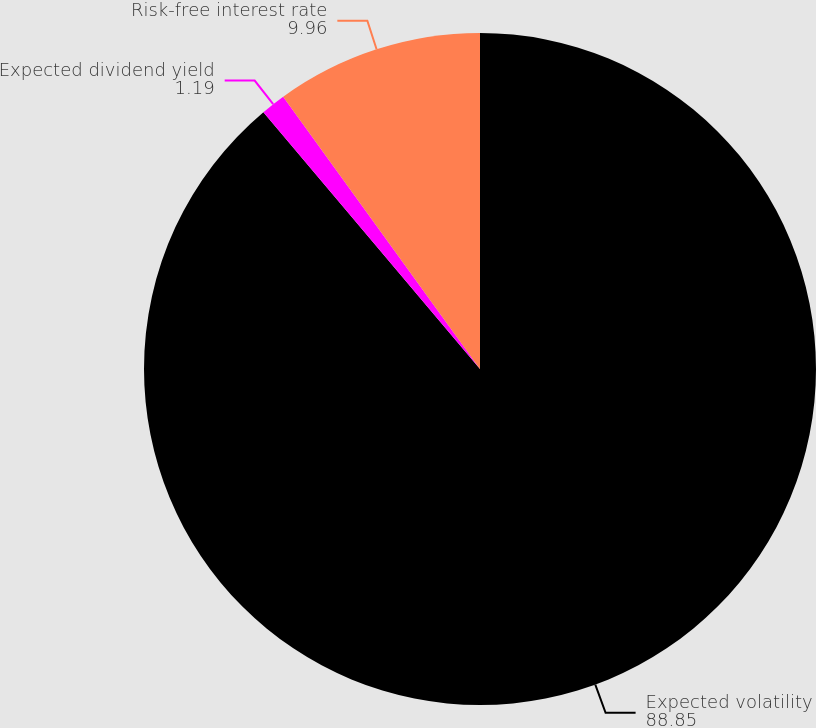<chart> <loc_0><loc_0><loc_500><loc_500><pie_chart><fcel>Expected volatility<fcel>Expected dividend yield<fcel>Risk-free interest rate<nl><fcel>88.85%<fcel>1.19%<fcel>9.96%<nl></chart> 